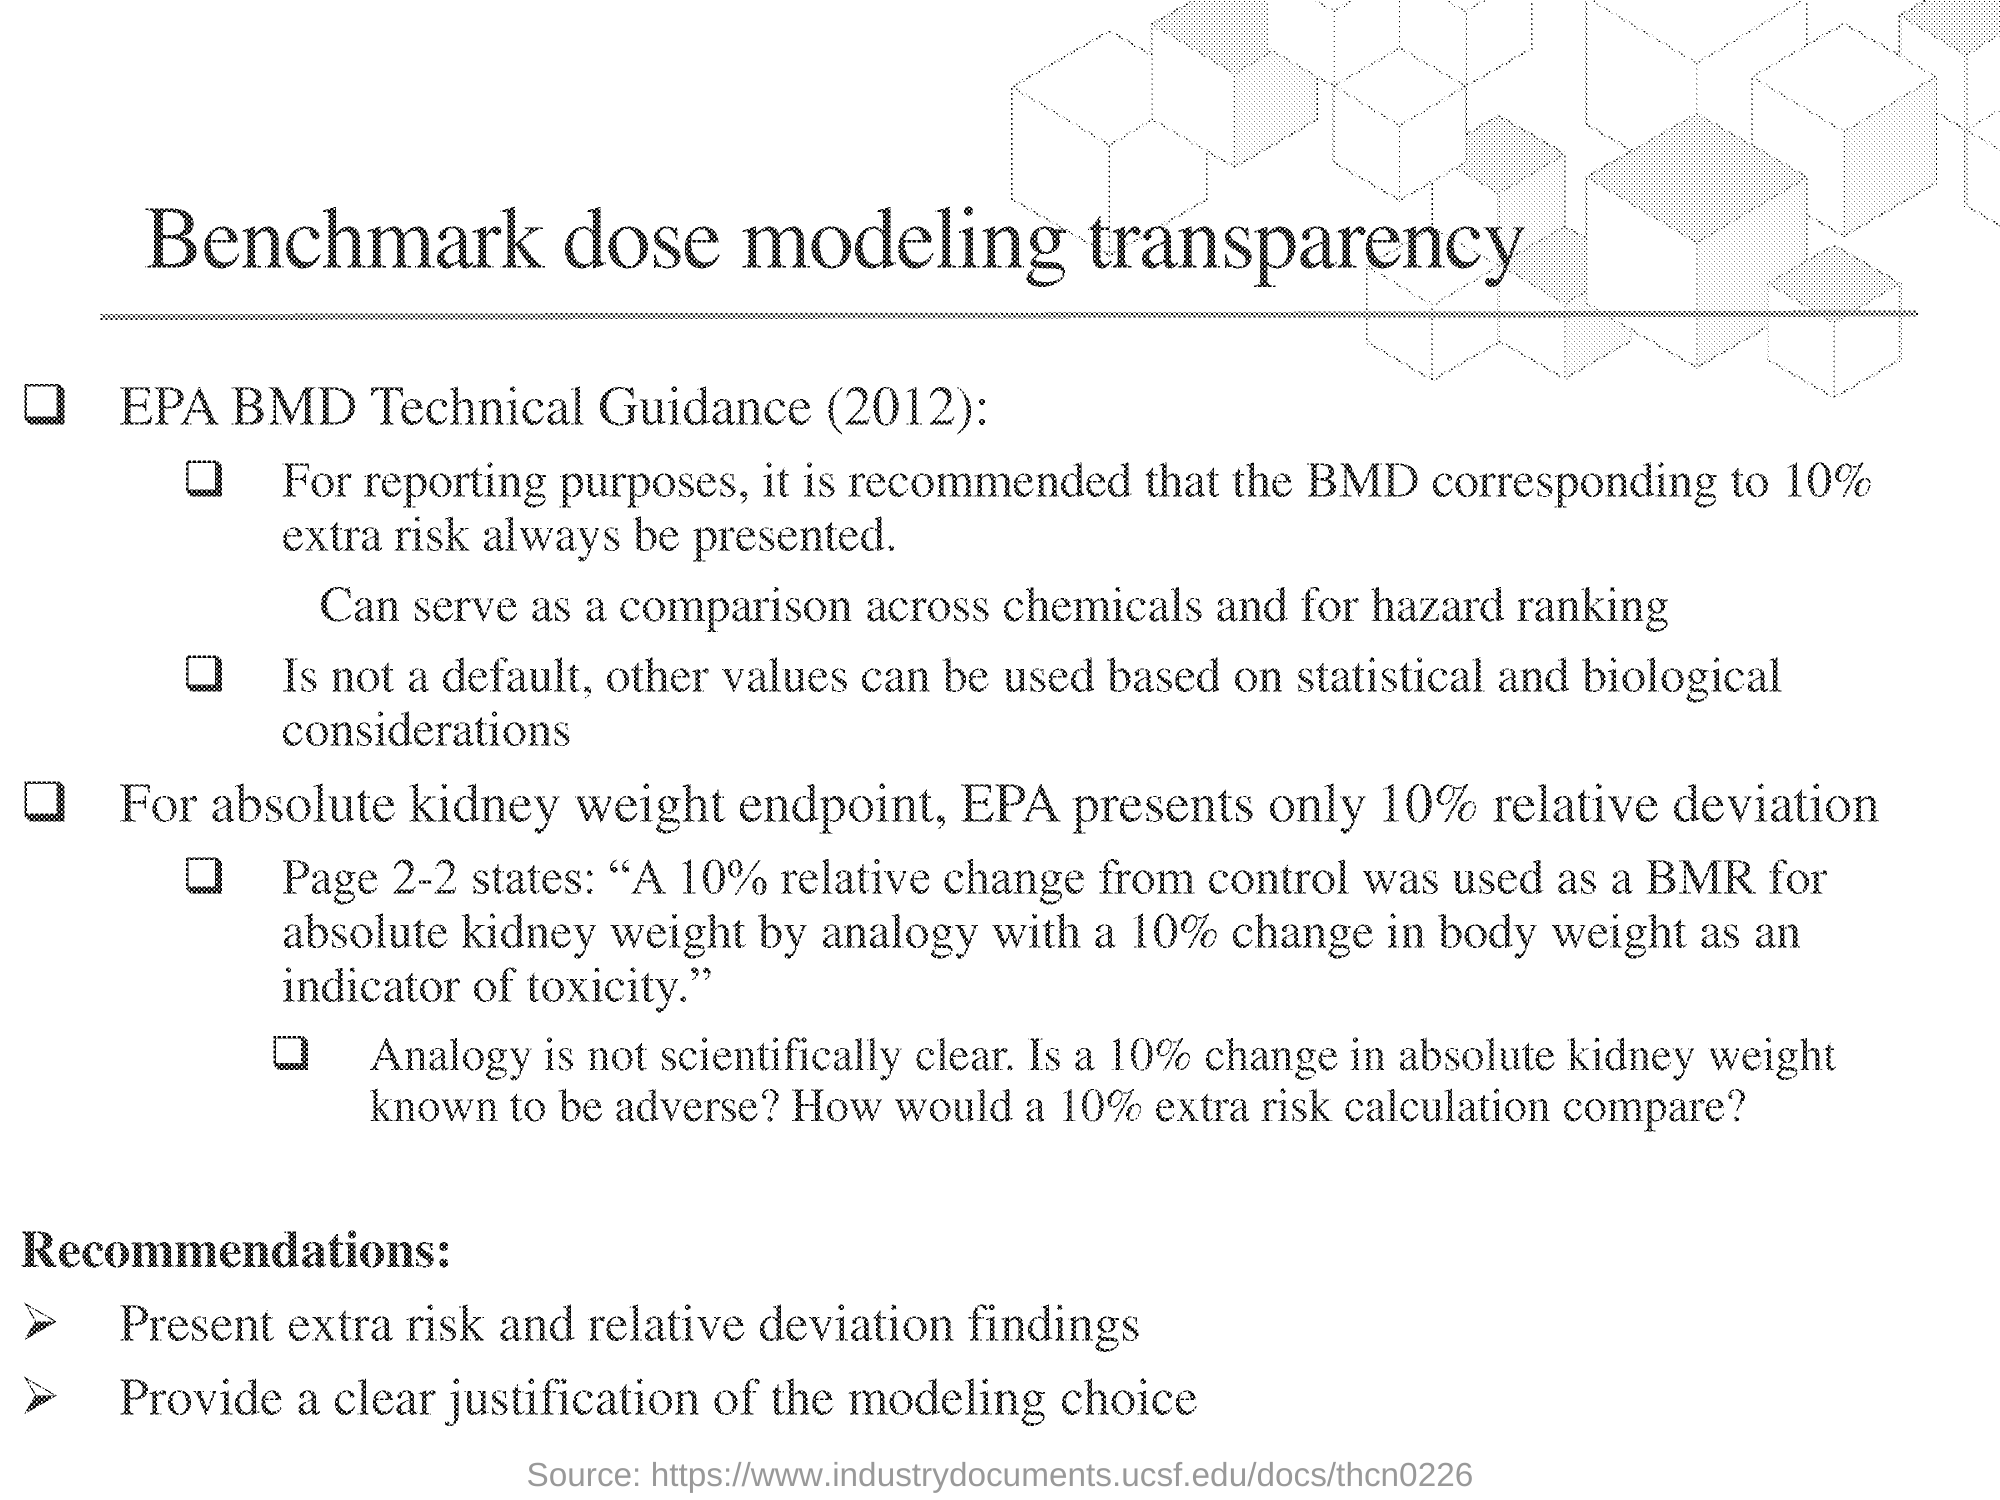Mention a couple of crucial points in this snapshot. The Environmental Protection Agency (EPA) presents a relative deviation of 10% for the absolute kidney weight endpoint. This document is titled 'Benchmark Dose Modeling Transparency.' 